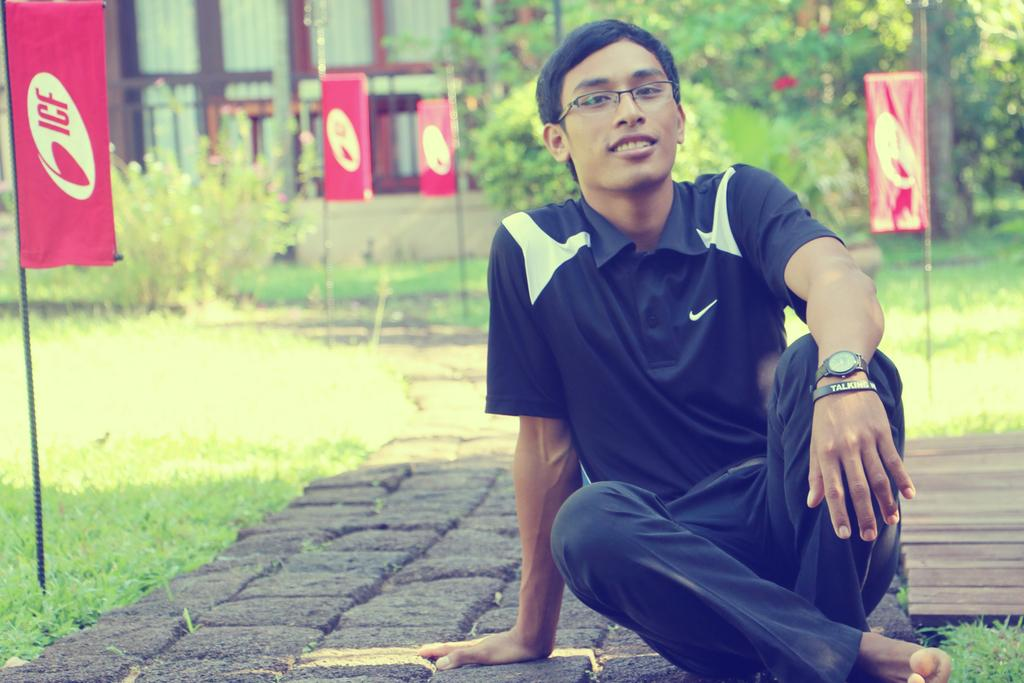What is the boy doing in the image? The boy is sitting on a path in the image. Can you describe the path the boy is sitting on? The path is between grass in the image. What can be seen in the grass near the path? There are flags dug in the grass in the image. What is visible in the background of the image? There are trees in the background of the image. How many rings does the boy have on his fingers in the image? There is no mention of rings in the image, so we cannot determine the number of rings the boy has on his fingers. 